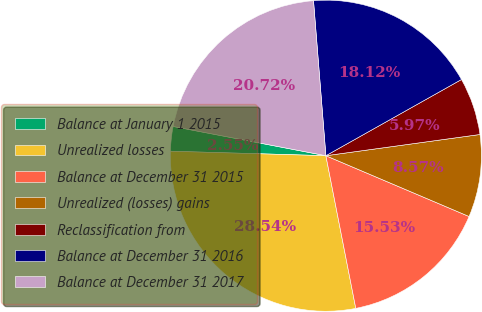Convert chart. <chart><loc_0><loc_0><loc_500><loc_500><pie_chart><fcel>Balance at January 1 2015<fcel>Unrealized losses<fcel>Balance at December 31 2015<fcel>Unrealized (losses) gains<fcel>Reclassification from<fcel>Balance at December 31 2016<fcel>Balance at December 31 2017<nl><fcel>2.55%<fcel>28.54%<fcel>15.53%<fcel>8.57%<fcel>5.97%<fcel>18.12%<fcel>20.72%<nl></chart> 